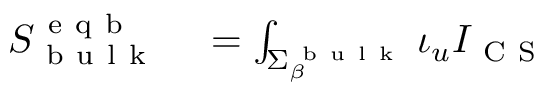<formula> <loc_0><loc_0><loc_500><loc_500>\begin{array} { r l } { S _ { b u l k } ^ { e q b } } & = \int _ { \Sigma _ { \beta } ^ { b u l k } } \iota _ { u } I _ { C S } } \end{array}</formula> 